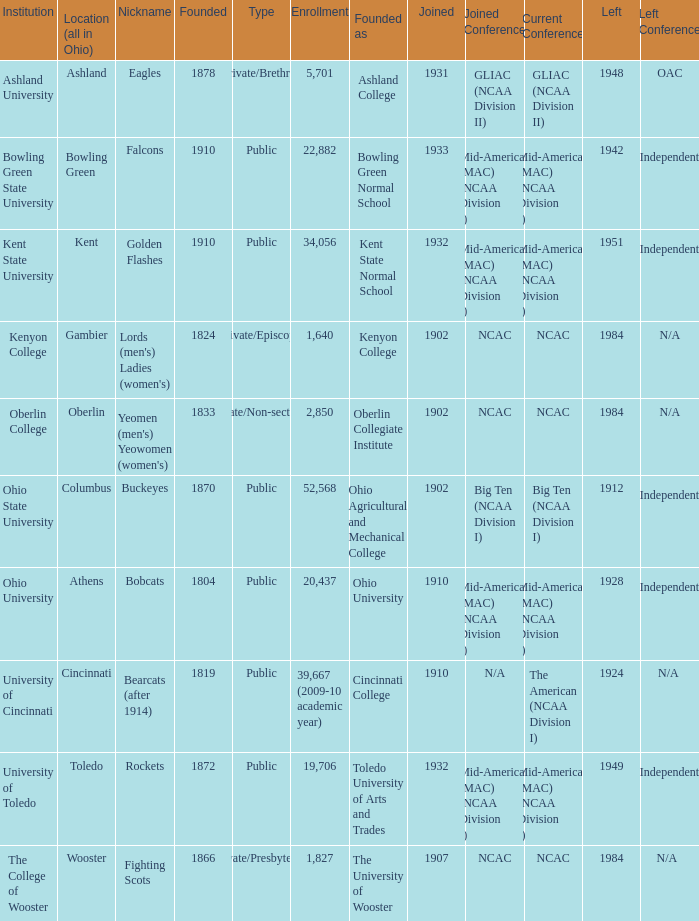Which year did enrolled Gambier members leave? 1984.0. 